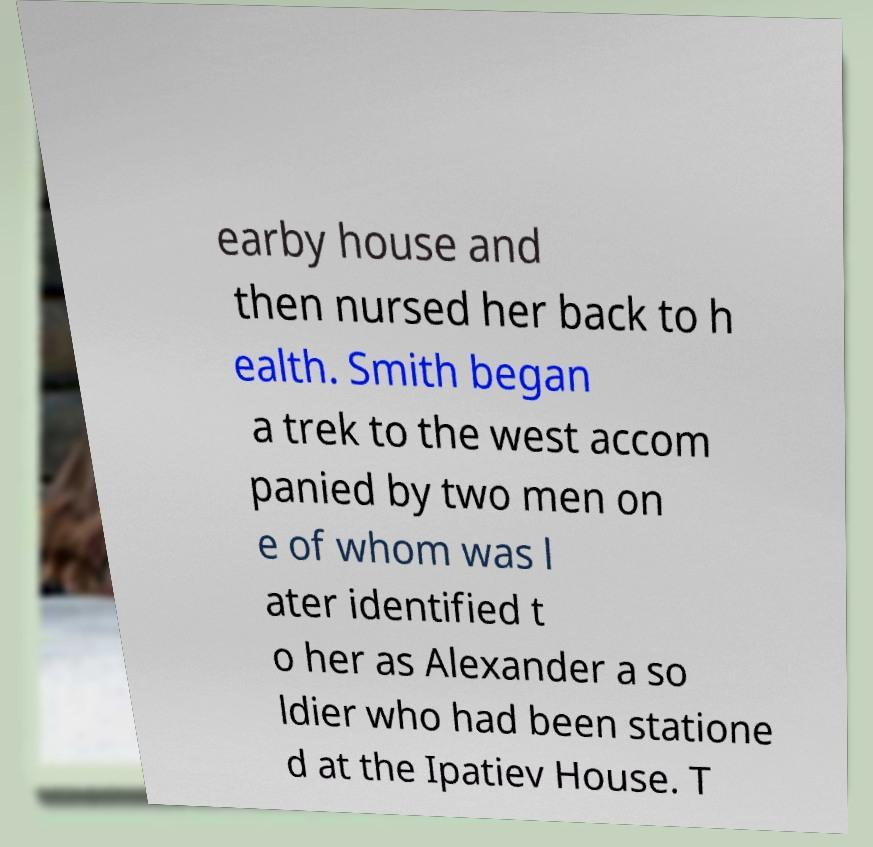Can you read and provide the text displayed in the image?This photo seems to have some interesting text. Can you extract and type it out for me? earby house and then nursed her back to h ealth. Smith began a trek to the west accom panied by two men on e of whom was l ater identified t o her as Alexander a so ldier who had been statione d at the Ipatiev House. T 